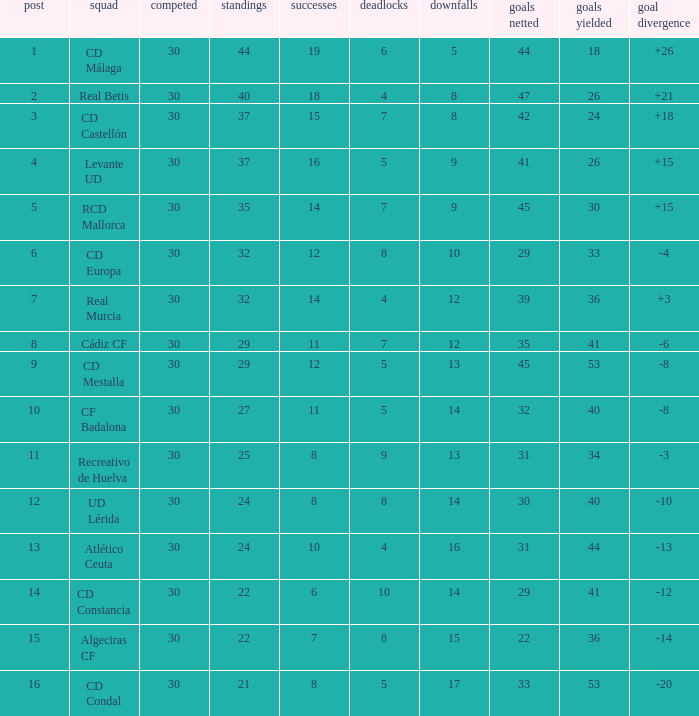What is the number of losses when the goal difference was -8, and position is smaller than 10? 1.0. 